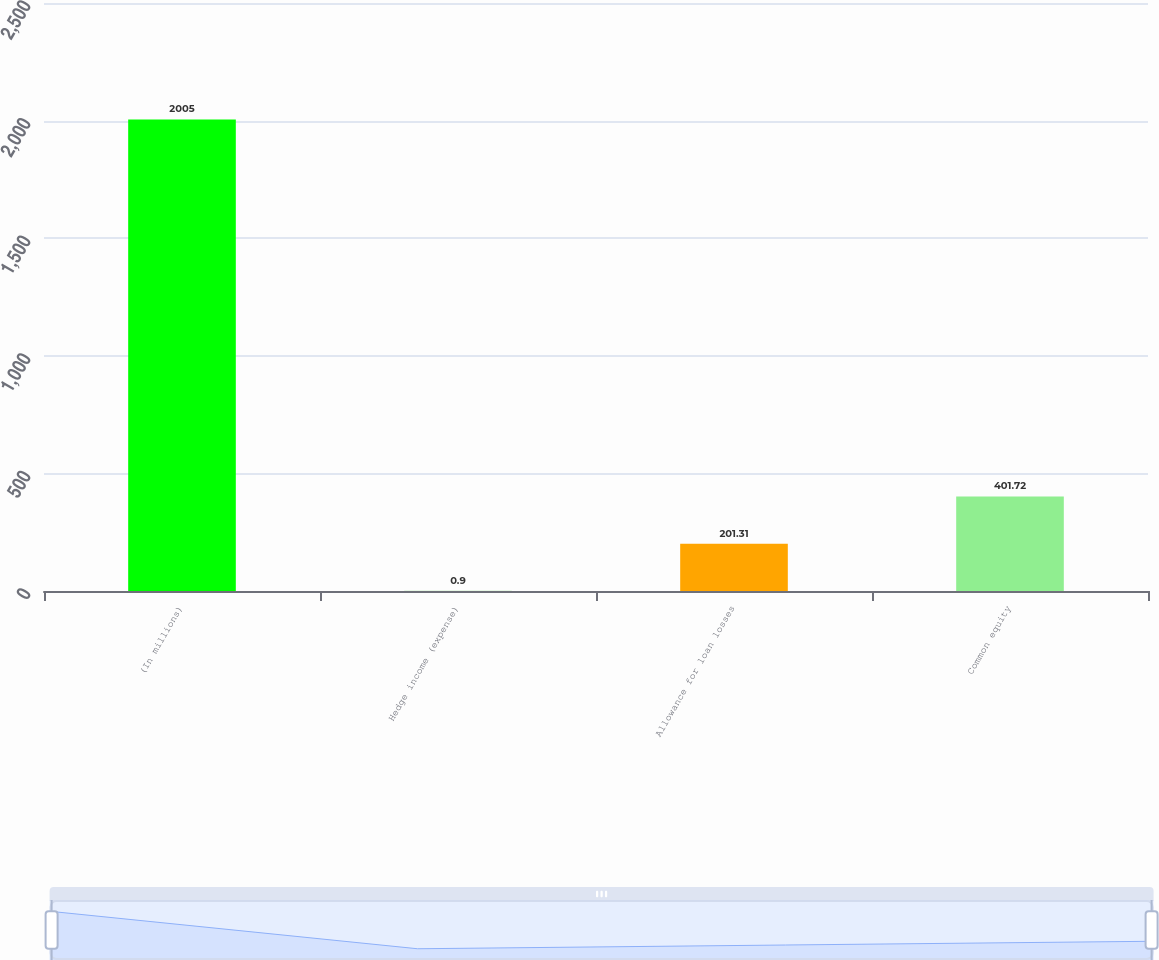Convert chart. <chart><loc_0><loc_0><loc_500><loc_500><bar_chart><fcel>(In millions)<fcel>Hedge income (expense)<fcel>Allowance for loan losses<fcel>Common equity<nl><fcel>2005<fcel>0.9<fcel>201.31<fcel>401.72<nl></chart> 